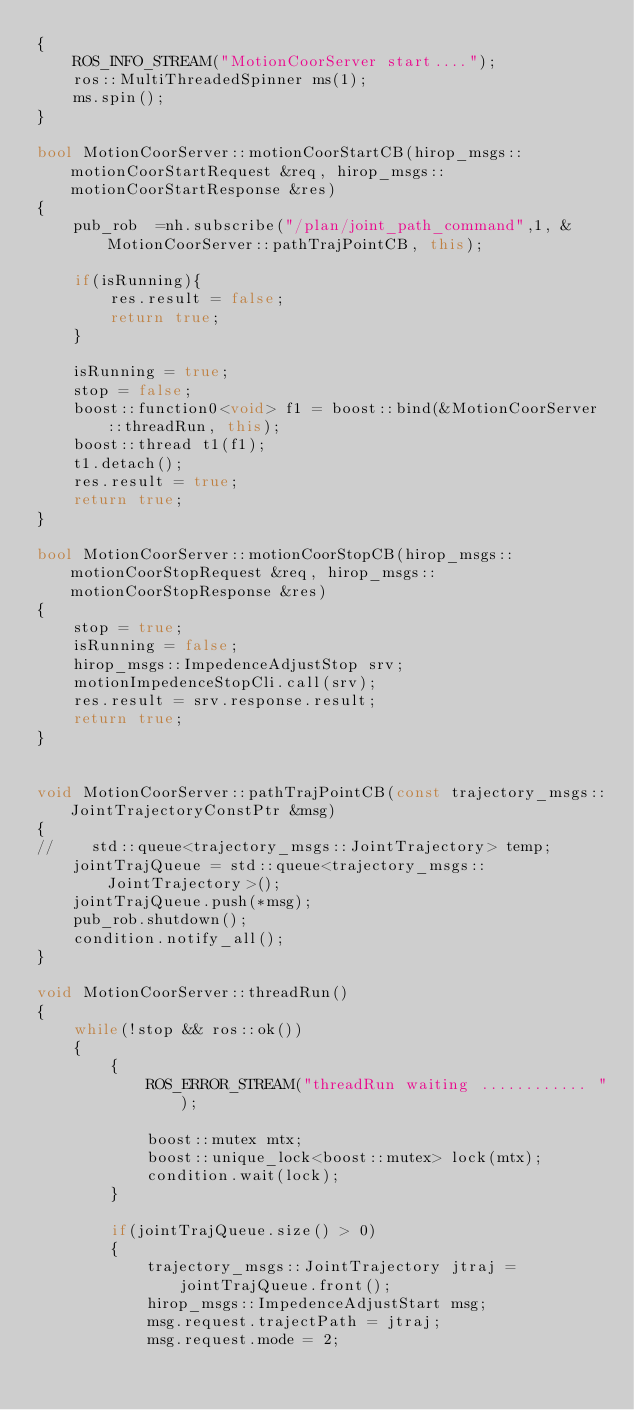<code> <loc_0><loc_0><loc_500><loc_500><_C++_>{
    ROS_INFO_STREAM("MotionCoorServer start....");
    ros::MultiThreadedSpinner ms(1);
    ms.spin();
}

bool MotionCoorServer::motionCoorStartCB(hirop_msgs::motionCoorStartRequest &req, hirop_msgs::motionCoorStartResponse &res)
{
    pub_rob  =nh.subscribe("/plan/joint_path_command",1, &MotionCoorServer::pathTrajPointCB, this);

    if(isRunning){
        res.result = false;
        return true;
    }

    isRunning = true;
    stop = false;
    boost::function0<void> f1 = boost::bind(&MotionCoorServer::threadRun, this);
    boost::thread t1(f1);
    t1.detach();
    res.result = true;
    return true;
}

bool MotionCoorServer::motionCoorStopCB(hirop_msgs::motionCoorStopRequest &req, hirop_msgs::motionCoorStopResponse &res)
{
    stop = true;
    isRunning = false;
    hirop_msgs::ImpedenceAdjustStop srv;
    motionImpedenceStopCli.call(srv);
    res.result = srv.response.result;
    return true;
}


void MotionCoorServer::pathTrajPointCB(const trajectory_msgs::JointTrajectoryConstPtr &msg)
{
//    std::queue<trajectory_msgs::JointTrajectory> temp;
    jointTrajQueue = std::queue<trajectory_msgs::JointTrajectory>();
    jointTrajQueue.push(*msg);
    pub_rob.shutdown();
    condition.notify_all();
}

void MotionCoorServer::threadRun()
{
    while(!stop && ros::ok())
    {
        {
            ROS_ERROR_STREAM("threadRun waiting ............ ");

            boost::mutex mtx;
            boost::unique_lock<boost::mutex> lock(mtx);
            condition.wait(lock);
        }

        if(jointTrajQueue.size() > 0)
        {
            trajectory_msgs::JointTrajectory jtraj = jointTrajQueue.front();
            hirop_msgs::ImpedenceAdjustStart msg;
            msg.request.trajectPath = jtraj;
            msg.request.mode = 2;</code> 